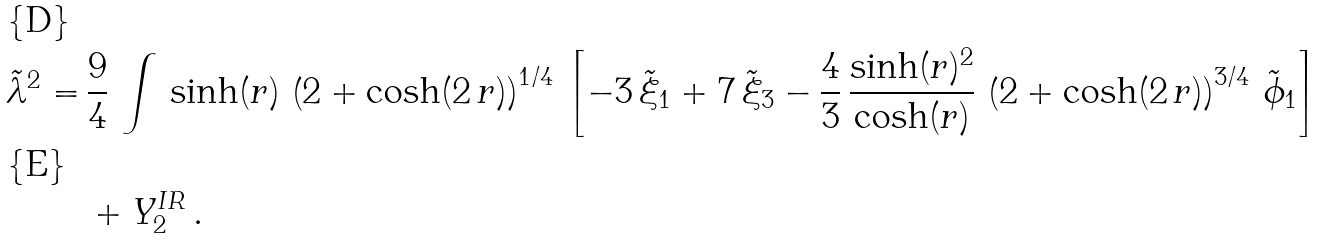<formula> <loc_0><loc_0><loc_500><loc_500>\tilde { \lambda } ^ { 2 } = & \, \frac { 9 } { 4 } \, \int \, \sinh ( r ) \, \left ( 2 + \cosh ( 2 \, r ) \right ) ^ { 1 / 4 } \, \left [ - 3 \, \tilde { \xi } _ { 1 } + 7 \, \tilde { \xi } _ { 3 } - \frac { 4 } { 3 } \, \frac { \sinh ( r ) ^ { 2 } } { \cosh ( r ) } \, \left ( 2 + \cosh ( 2 \, r ) \right ) ^ { 3 / 4 } \, \tilde { \phi } _ { 1 } \right ] \\ & \, + Y _ { 2 } ^ { I R } \, .</formula> 